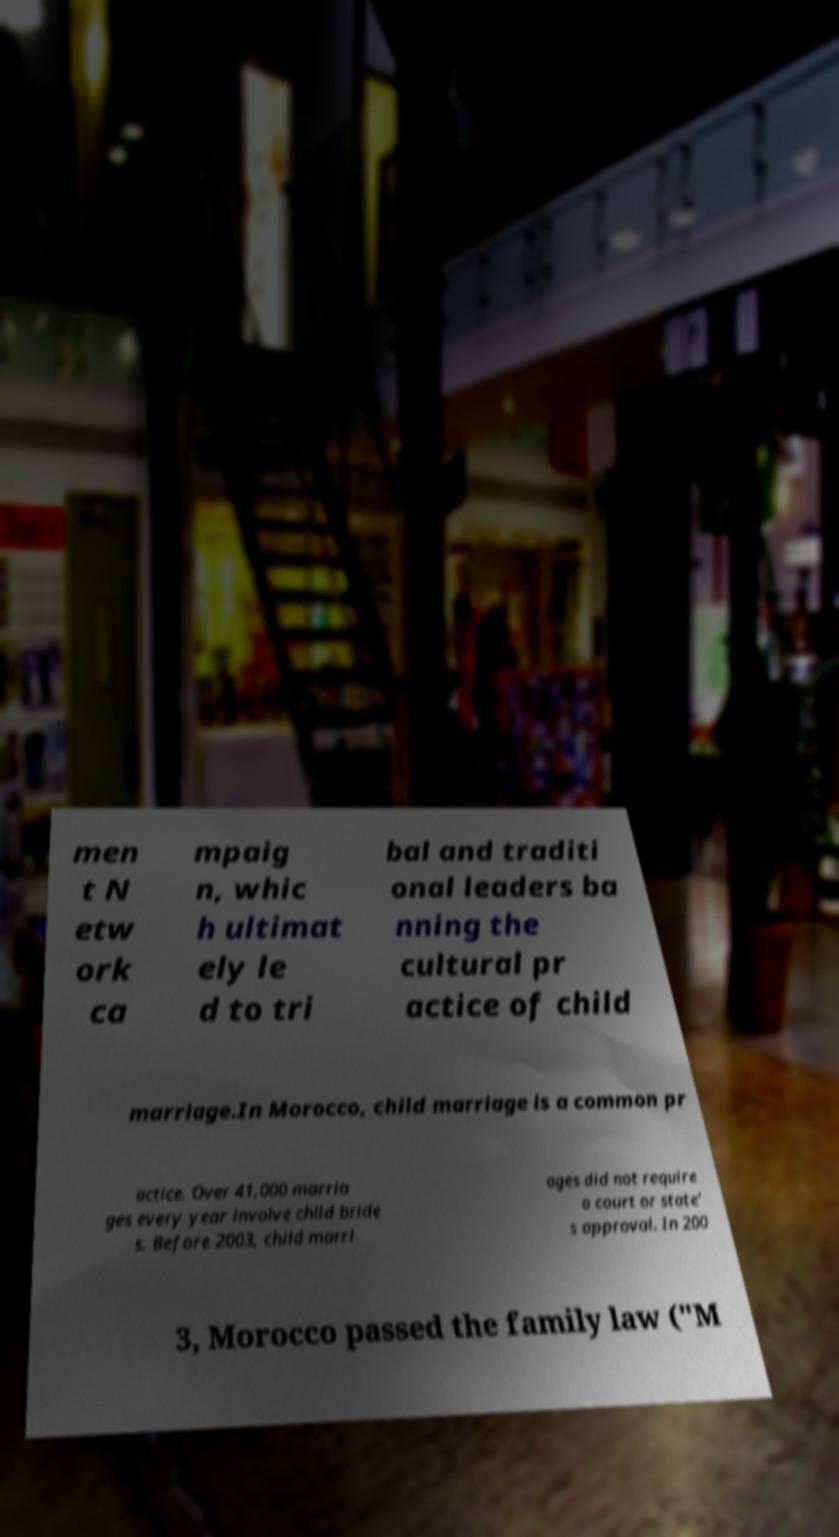Please read and relay the text visible in this image. What does it say? men t N etw ork ca mpaig n, whic h ultimat ely le d to tri bal and traditi onal leaders ba nning the cultural pr actice of child marriage.In Morocco, child marriage is a common pr actice. Over 41,000 marria ges every year involve child bride s. Before 2003, child marri ages did not require a court or state' s approval. In 200 3, Morocco passed the family law ("M 